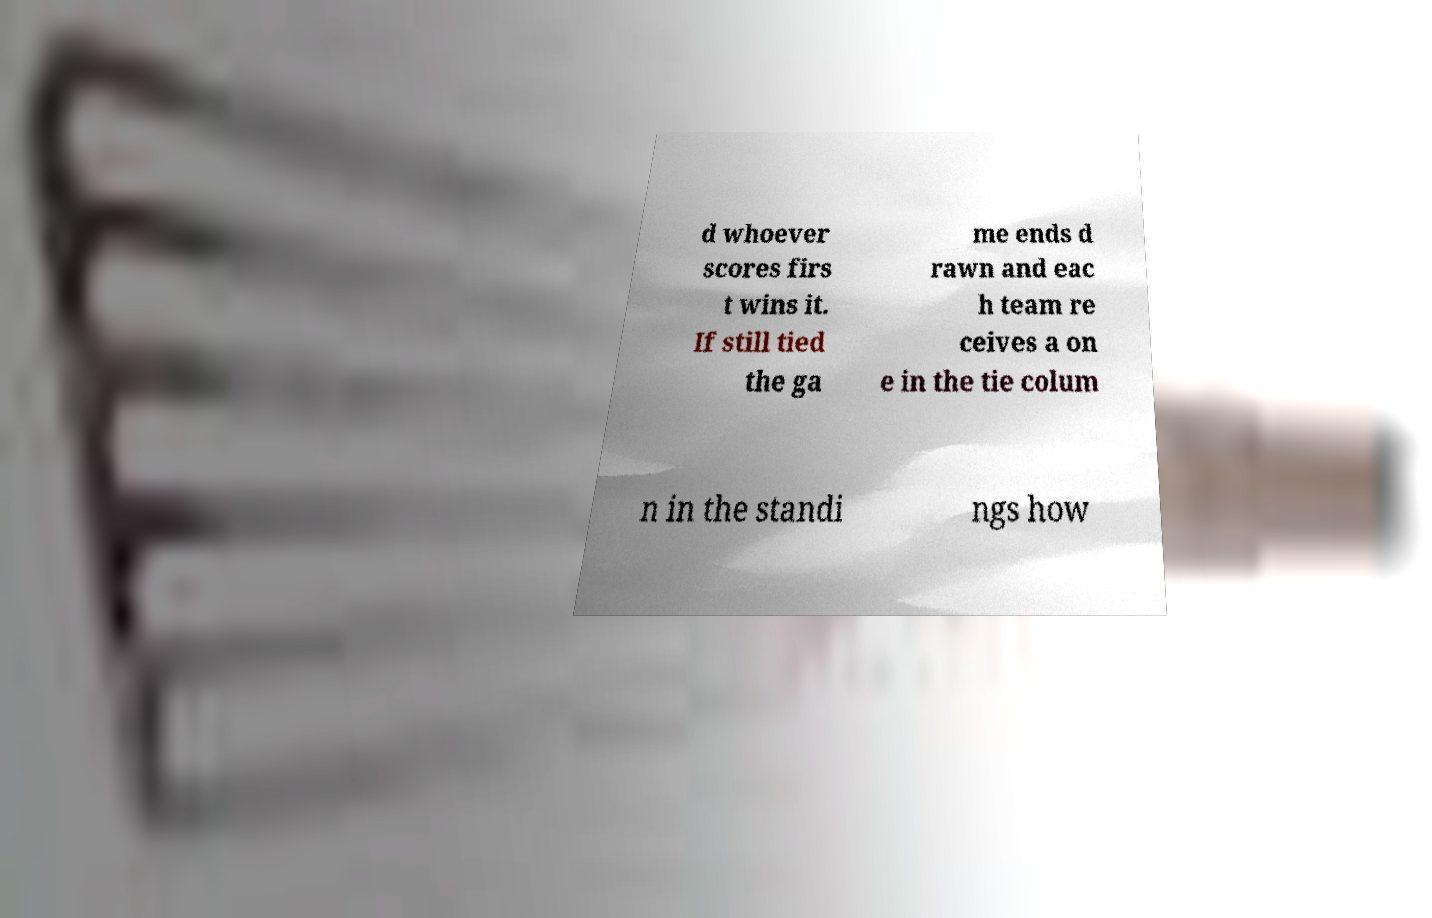Please read and relay the text visible in this image. What does it say? d whoever scores firs t wins it. If still tied the ga me ends d rawn and eac h team re ceives a on e in the tie colum n in the standi ngs how 